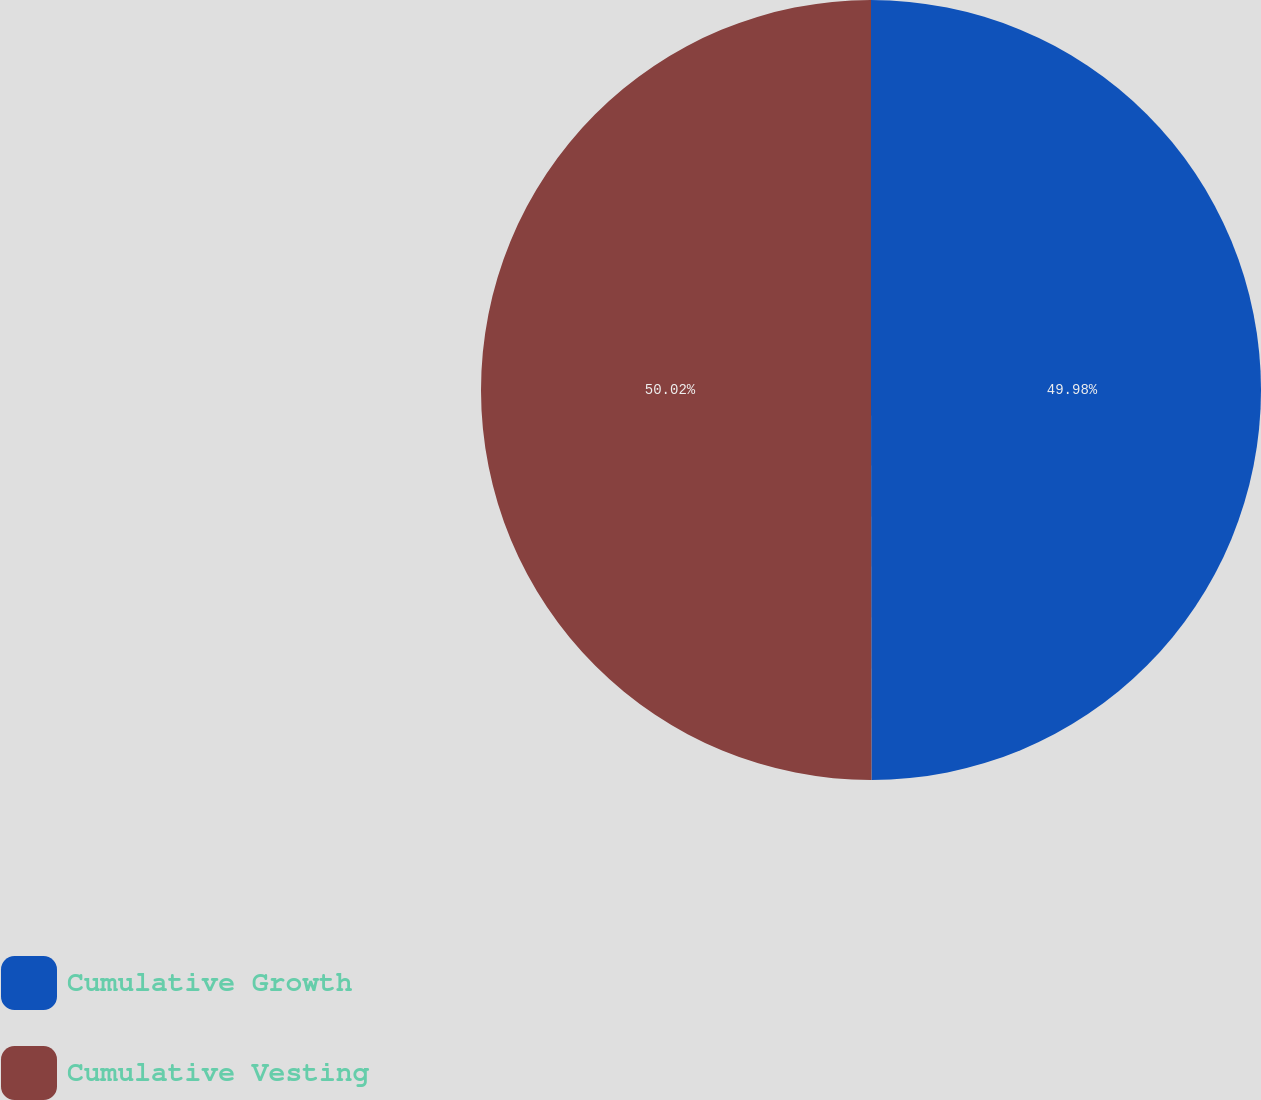Convert chart to OTSL. <chart><loc_0><loc_0><loc_500><loc_500><pie_chart><fcel>Cumulative Growth<fcel>Cumulative Vesting<nl><fcel>49.98%<fcel>50.02%<nl></chart> 